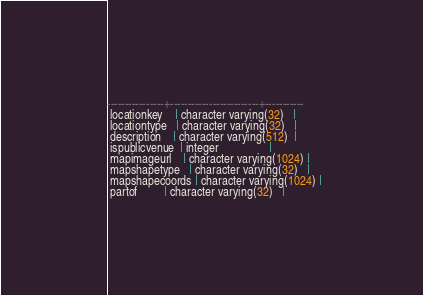Convert code to text. <code><loc_0><loc_0><loc_500><loc_500><_SQL_>----------------+-------------------------+-----------
 locationkey    | character varying(32)   | 
 locationtype   | character varying(32)   | 
 description    | character varying(512)  | 
 ispublicvenue  | integer                 | 
 mapimageurl    | character varying(1024) | 
 mapshapetype   | character varying(32)   | 
 mapshapecoords | character varying(1024) | 
 partof         | character varying(32)   | 

</code> 